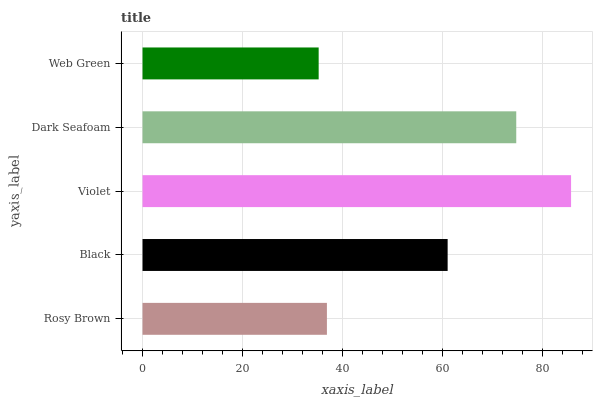Is Web Green the minimum?
Answer yes or no. Yes. Is Violet the maximum?
Answer yes or no. Yes. Is Black the minimum?
Answer yes or no. No. Is Black the maximum?
Answer yes or no. No. Is Black greater than Rosy Brown?
Answer yes or no. Yes. Is Rosy Brown less than Black?
Answer yes or no. Yes. Is Rosy Brown greater than Black?
Answer yes or no. No. Is Black less than Rosy Brown?
Answer yes or no. No. Is Black the high median?
Answer yes or no. Yes. Is Black the low median?
Answer yes or no. Yes. Is Rosy Brown the high median?
Answer yes or no. No. Is Violet the low median?
Answer yes or no. No. 